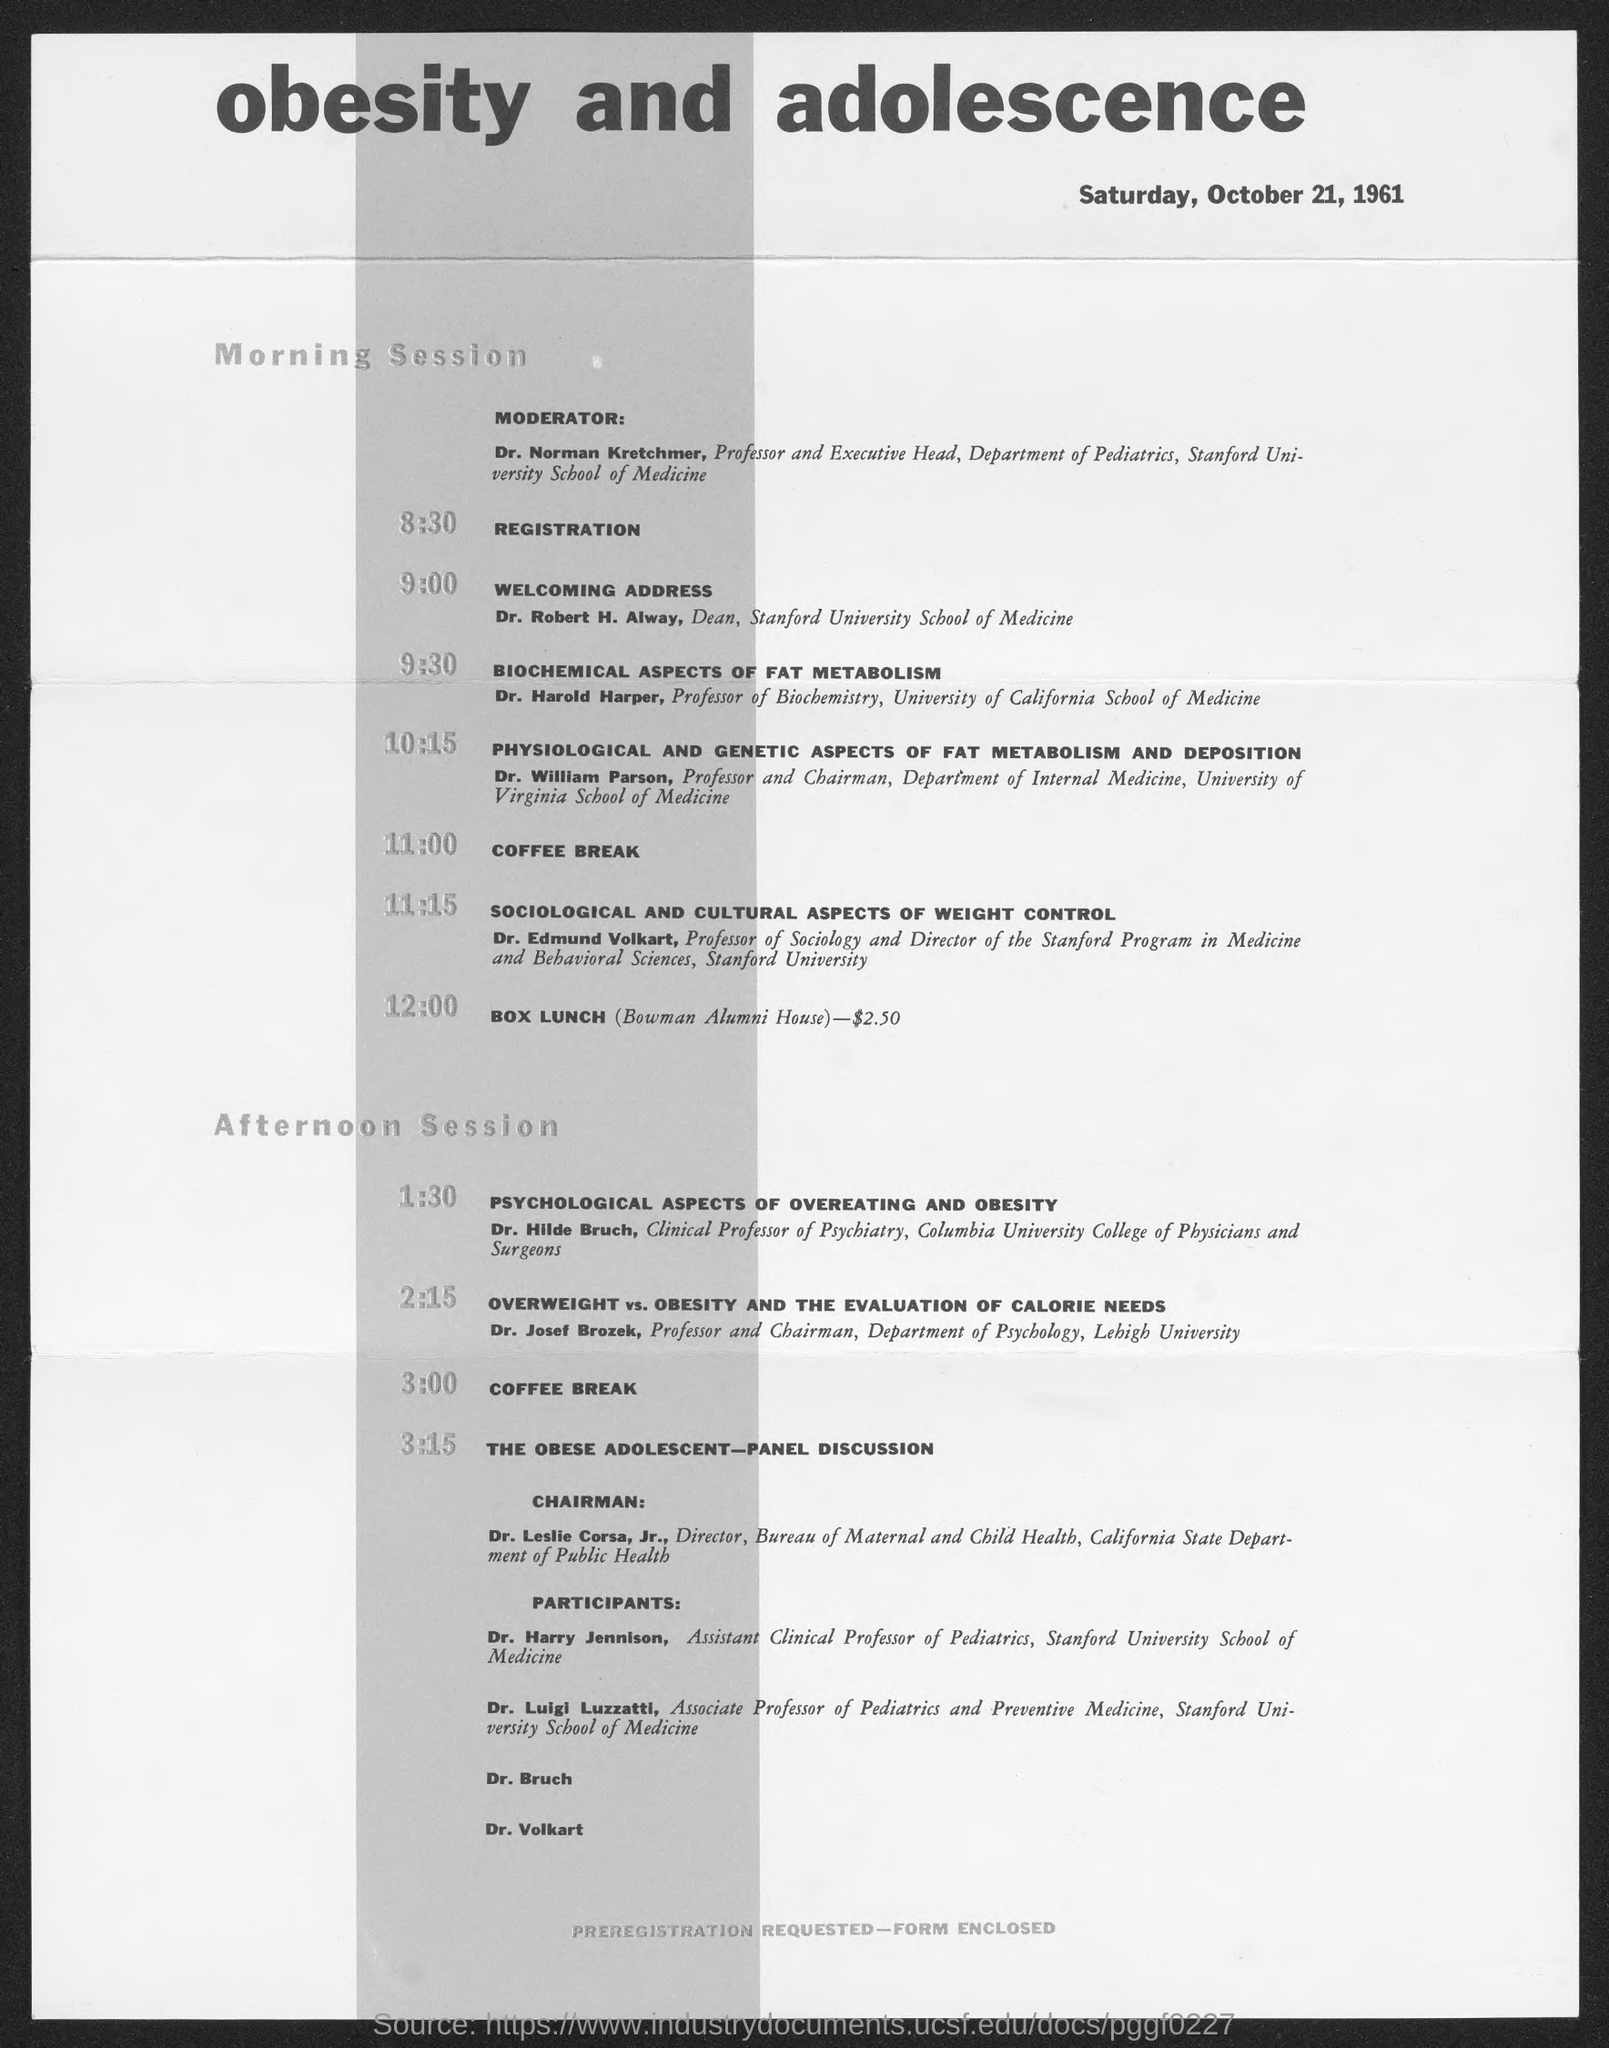Give some essential details in this illustration. The chairman for the "The Obese Adolescent - Panel Discussion" is Dr. Leslie Corsa, Jr. Dr. Robert H. Alway is the Dean of the Stanford University School of Medicine. Dr. Robert H. Alway will be delivering the welcoming address for the morning sessions. The morning session coffee break will take place at 11:00. The registration for the sessions will take place at 8:30. 